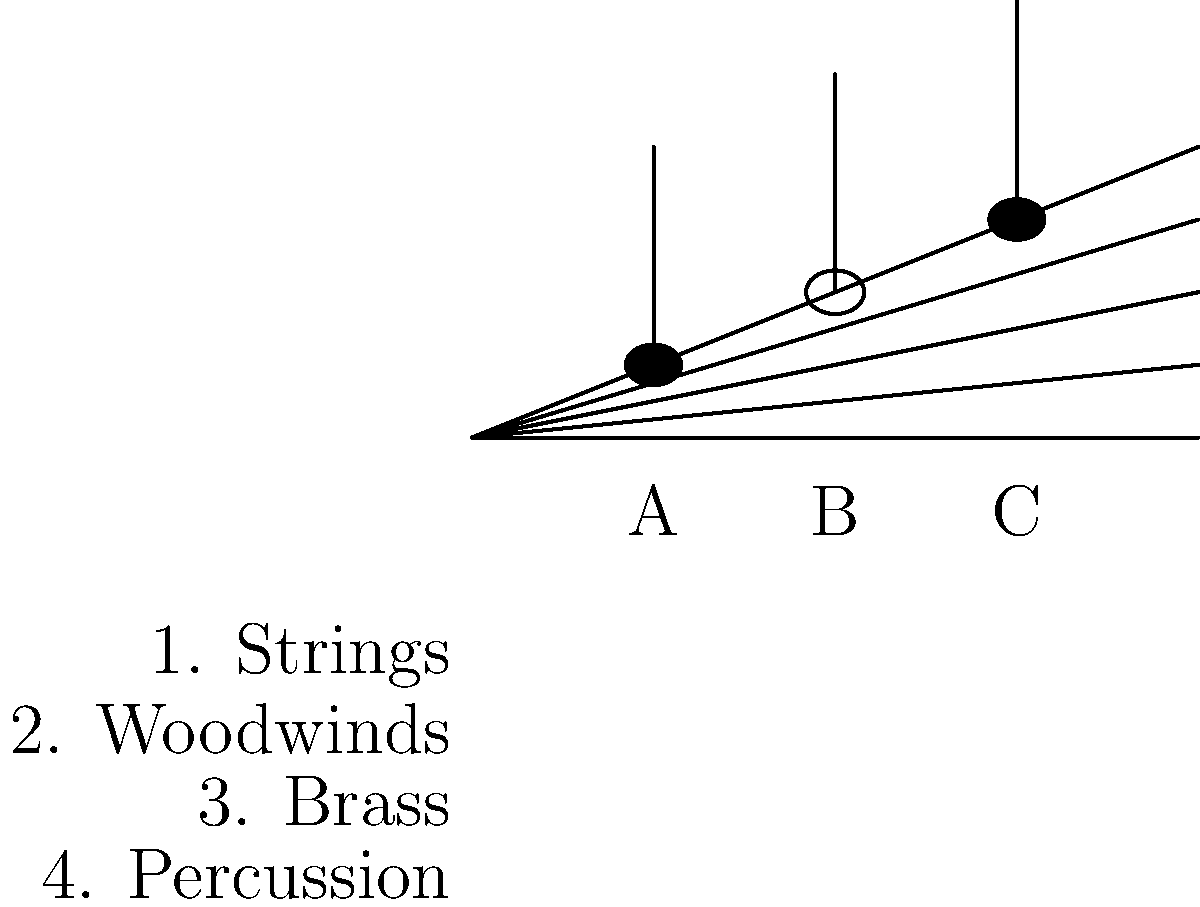Match each note (A, B, C) to the instrument family that would most likely play it in a typical orchestral setting, considering the pitch range and note duration. Choose from: 1. Strings, 2. Woodwinds, 3. Brass, 4. Percussion. To match the notes to the appropriate instrument families, we need to consider the pitch and duration of each note:

1. Note A: This is a quarter note on the first space of the staff, indicating a relatively low pitch. In orchestral music, lower pitches are often played by string instruments, particularly cellos or violas. Therefore, A matches with 1. Strings.

2. Note B: This is a half note on the second line of the staff, indicating a slightly higher pitch than A and a longer duration. Woodwind instruments, such as clarinets or oboes, often play middle-range notes with longer durations. Thus, B matches with 2. Woodwinds.

3. Note C: This is a quarter note on the third space of the staff, indicating the highest pitch of the three notes. In orchestral settings, higher pitches are frequently assigned to brass instruments like trumpets or French horns, especially for shorter note durations. Therefore, C matches with 3. Brass.

It's important to note that while percussion instruments are crucial to orchestral music, they typically don't play pitched notes on a standard musical staff, which is why they are not matched with any of the given notes in this example.
Answer: A-1, B-2, C-3 